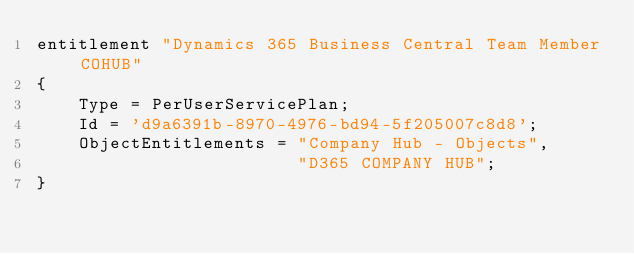Convert code to text. <code><loc_0><loc_0><loc_500><loc_500><_Perl_>entitlement "Dynamics 365 Business Central Team Member COHUB"
{
    Type = PerUserServicePlan;
    Id = 'd9a6391b-8970-4976-bd94-5f205007c8d8';
    ObjectEntitlements = "Company Hub - Objects",
                         "D365 COMPANY HUB";
}
</code> 